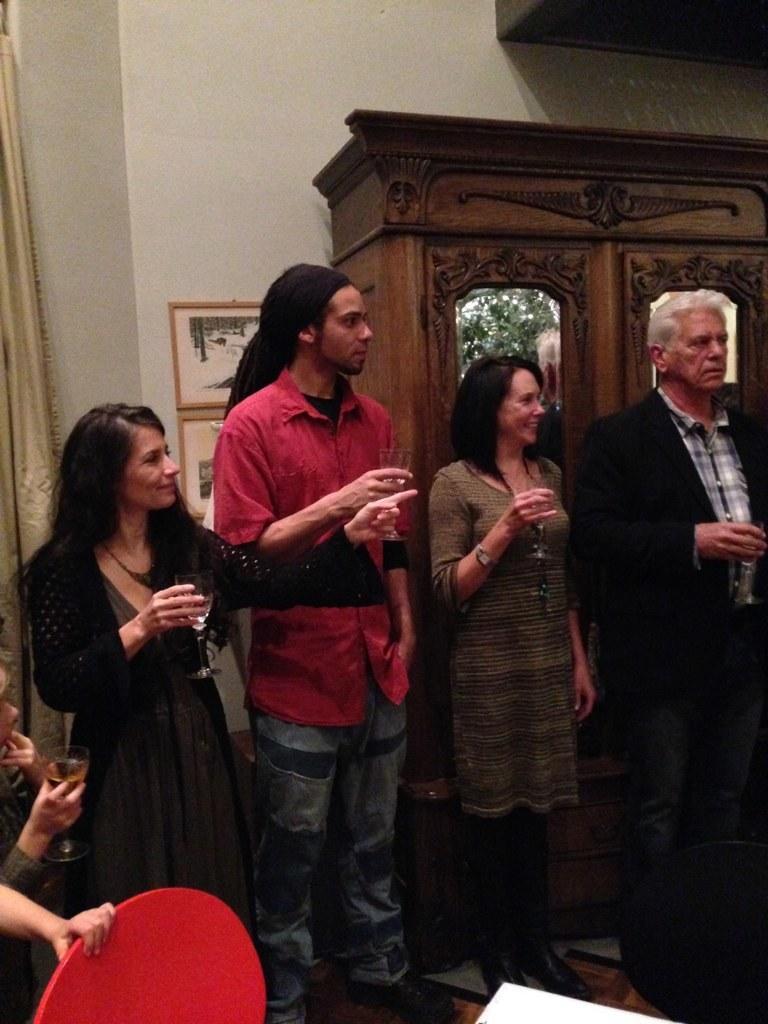Describe this image in one or two sentences. In the image there were some people ,coming to the right corner one man is standing with holding wine glass beside him the woman she is also holding the wine glass ,and she was laughing we can see on her face. And coming to the left corner there was a woman she is also holding a glass. Beside her there is a man he was just watching what is going there and coming to the bottom of the left there is a person he is also holding glass with wine. And beside him we can see some person hand he is holding chair. these persons were surrounding with full of objects. Coming to the background there was a wall and here the dressing table with the photo frame and left corner there was a curtain. 